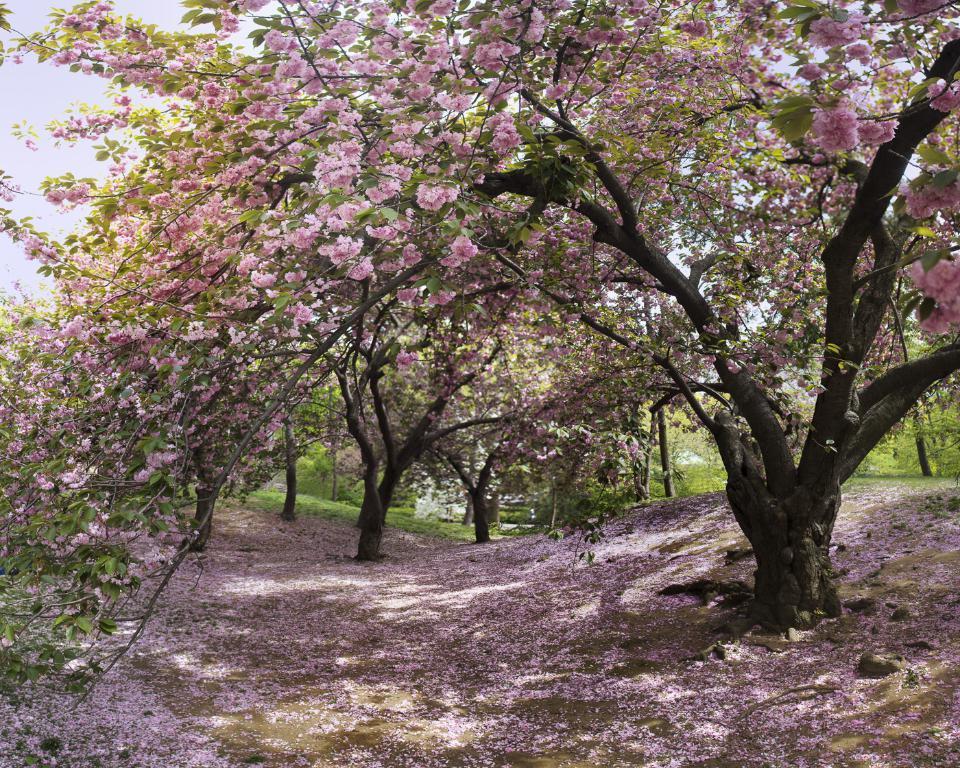In one or two sentences, can you explain what this image depicts? In the picture I can see trees and the grass. In the background I can see the sky and flowers on the ground. These flowers are pink in color. 